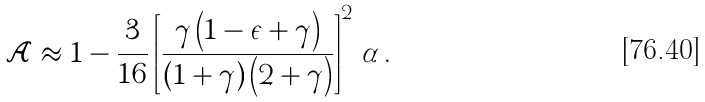Convert formula to latex. <formula><loc_0><loc_0><loc_500><loc_500>\mathcal { A } \approx 1 - \frac { 3 } { 1 6 } \left [ { \frac { \gamma \left ( 1 - \epsilon + \gamma \right ) } { ( 1 + \gamma ) \left ( 2 + \gamma \right ) } } \right ] ^ { 2 } \, \alpha \, .</formula> 